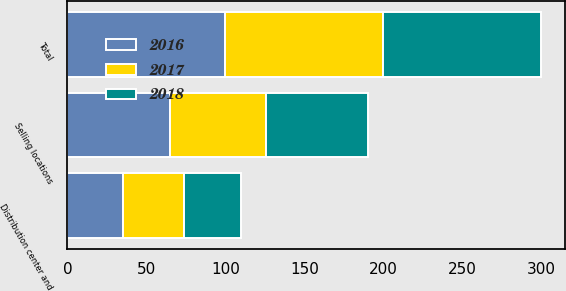Convert chart. <chart><loc_0><loc_0><loc_500><loc_500><stacked_bar_chart><ecel><fcel>Selling locations<fcel>Distribution center and<fcel>Total<nl><fcel>2017<fcel>61<fcel>39<fcel>100<nl><fcel>2016<fcel>65<fcel>35<fcel>100<nl><fcel>2018<fcel>64<fcel>36<fcel>100<nl></chart> 